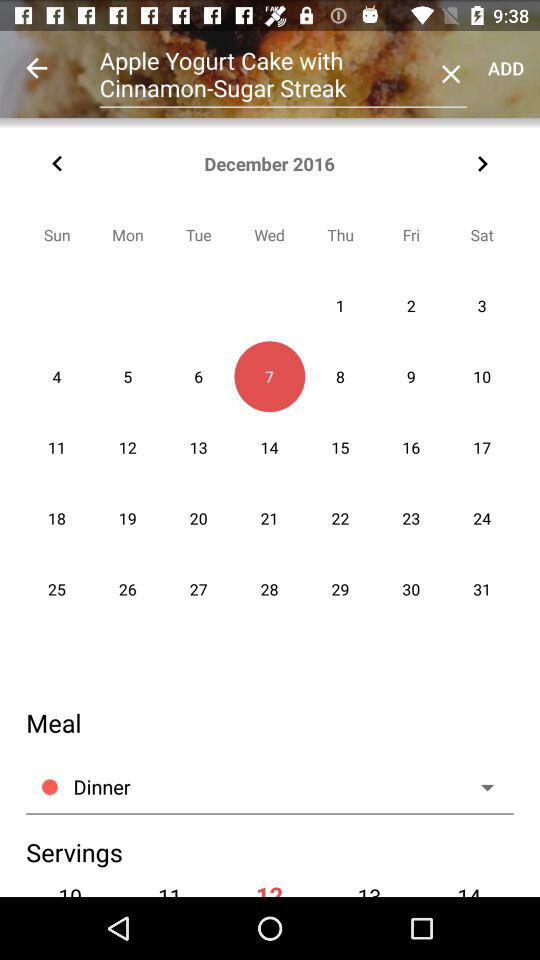What is the selected date? The selected date is Wednesday, December 7, 2016. 